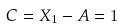<formula> <loc_0><loc_0><loc_500><loc_500>C = X _ { 1 } - A = 1</formula> 